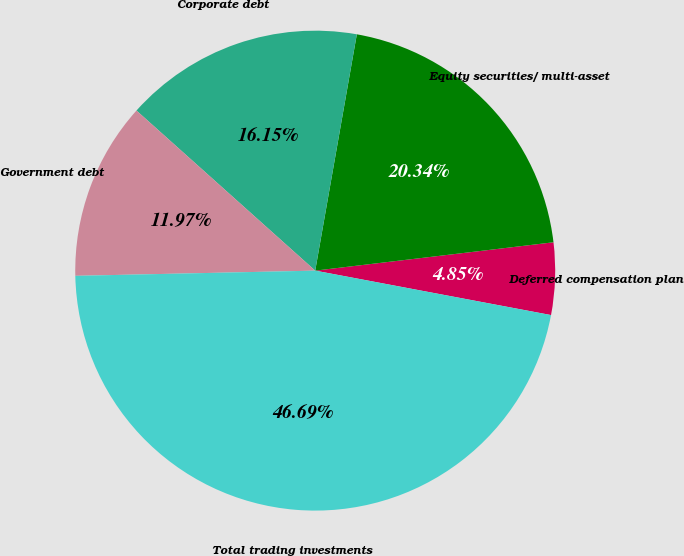Convert chart to OTSL. <chart><loc_0><loc_0><loc_500><loc_500><pie_chart><fcel>Deferred compensation plan<fcel>Equity securities/ multi-asset<fcel>Corporate debt<fcel>Government debt<fcel>Total trading investments<nl><fcel>4.85%<fcel>20.34%<fcel>16.15%<fcel>11.97%<fcel>46.69%<nl></chart> 